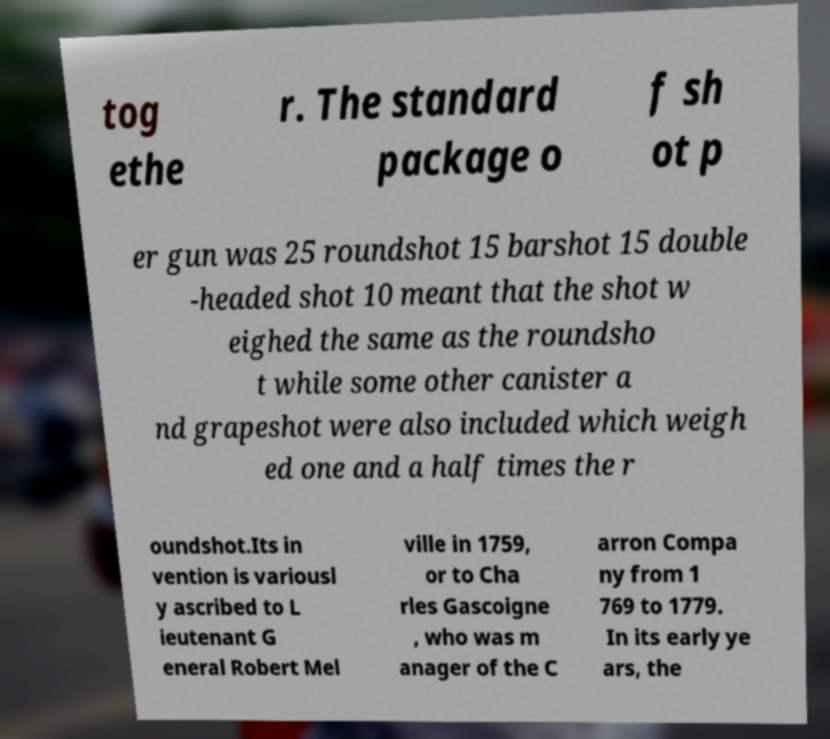Can you accurately transcribe the text from the provided image for me? tog ethe r. The standard package o f sh ot p er gun was 25 roundshot 15 barshot 15 double -headed shot 10 meant that the shot w eighed the same as the roundsho t while some other canister a nd grapeshot were also included which weigh ed one and a half times the r oundshot.Its in vention is variousl y ascribed to L ieutenant G eneral Robert Mel ville in 1759, or to Cha rles Gascoigne , who was m anager of the C arron Compa ny from 1 769 to 1779. In its early ye ars, the 